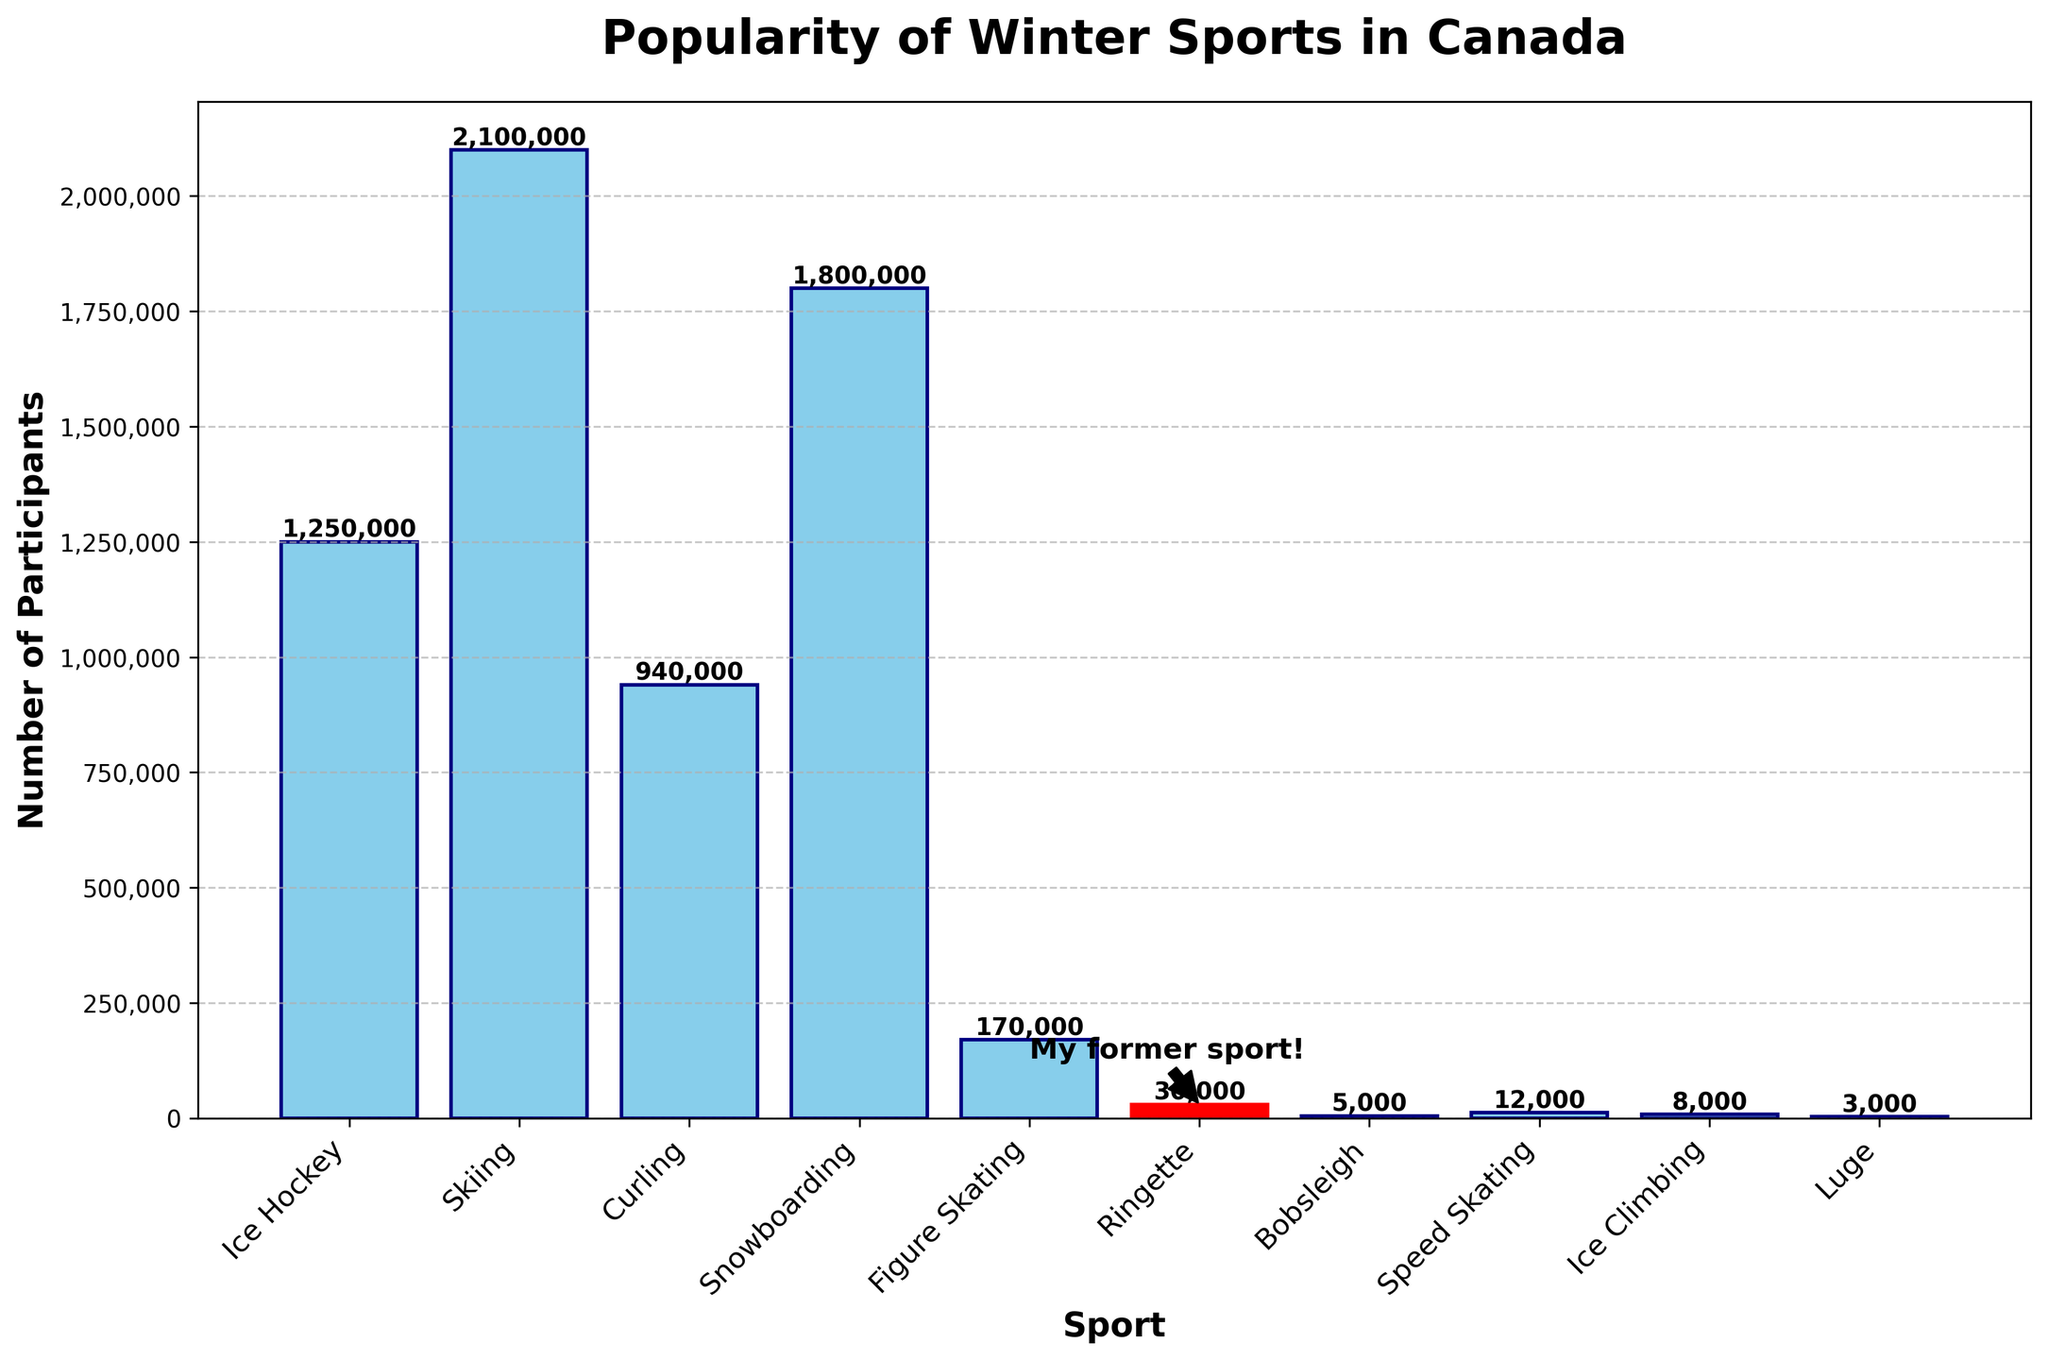Which sport has the highest number of participants? To determine this, look at the highest bar in the chart. "Skiing" is visually the tallest, indicating the most participants.
Answer: Skiing Which sport has fewer participants, Ringette or Figure Skating? Compare the heights of the bars for Ringette and Figure Skating. The Ringette bar is much shorter than the Figure Skating bar, indicating fewer participants.
Answer: Ringette What's the total number of participants for Ice Climbing and Luge combined? Add the values of the participants for Ice Climbing (8,000) and Luge (3,000): 8,000 + 3,000 = 11,000.
Answer: 11,000 How many more participants does Snowboarding have compared to Ice Hockey? Subtract the number of participants in Ice Hockey from those in Snowboarding: 1,800,000 - 1,250,000 = 550,000.
Answer: 550,000 Is the number of participants in Curling greater than in Speed Skating? Compare the bar heights for Curling and Speed Skating. The Curling bar is significantly taller than the Speed Skating bar.
Answer: Yes What are the sports with the least and most participants? The shortest and tallest bars indicate the sports with the least and most participants. Luge has the least participants, while Skiing has the most.
Answer: Luge and Skiing What's the difference in participants between the highest and lowest sport? Subtract the participants in the least popular sport (Luge, 3,000) from the most popular sport (Skiing, 2,100,000): 2,100,000 - 3,000 = 2,097,000.
Answer: 2,097,000 Which sport is highlighted in a different color? Visually identify the sport with a differently colored bar. The Ringette bar is highlighted in red.
Answer: Ringette How many sports have over 1,000,000 participants? Count the number of bars with heights indicating more than 1,000,000 participants (Ice Hockey, Skiing, Snowboarding).
Answer: 3 Which sports have fewer participants than Figure Skating? Identify and list bars shorter than the Figure Skating bar. These are Ringette, Bobsleigh, Speed Skating, Ice Climbing, and Luge.
Answer: Ringette, Bobsleigh, Speed Skating, Ice Climbing, and Luge 